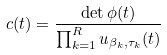<formula> <loc_0><loc_0><loc_500><loc_500>c ( t ) = \frac { \det \phi ( t ) } { \prod _ { k = 1 } ^ { R } u _ { \beta _ { k } , \tau _ { k } } ( t ) }</formula> 